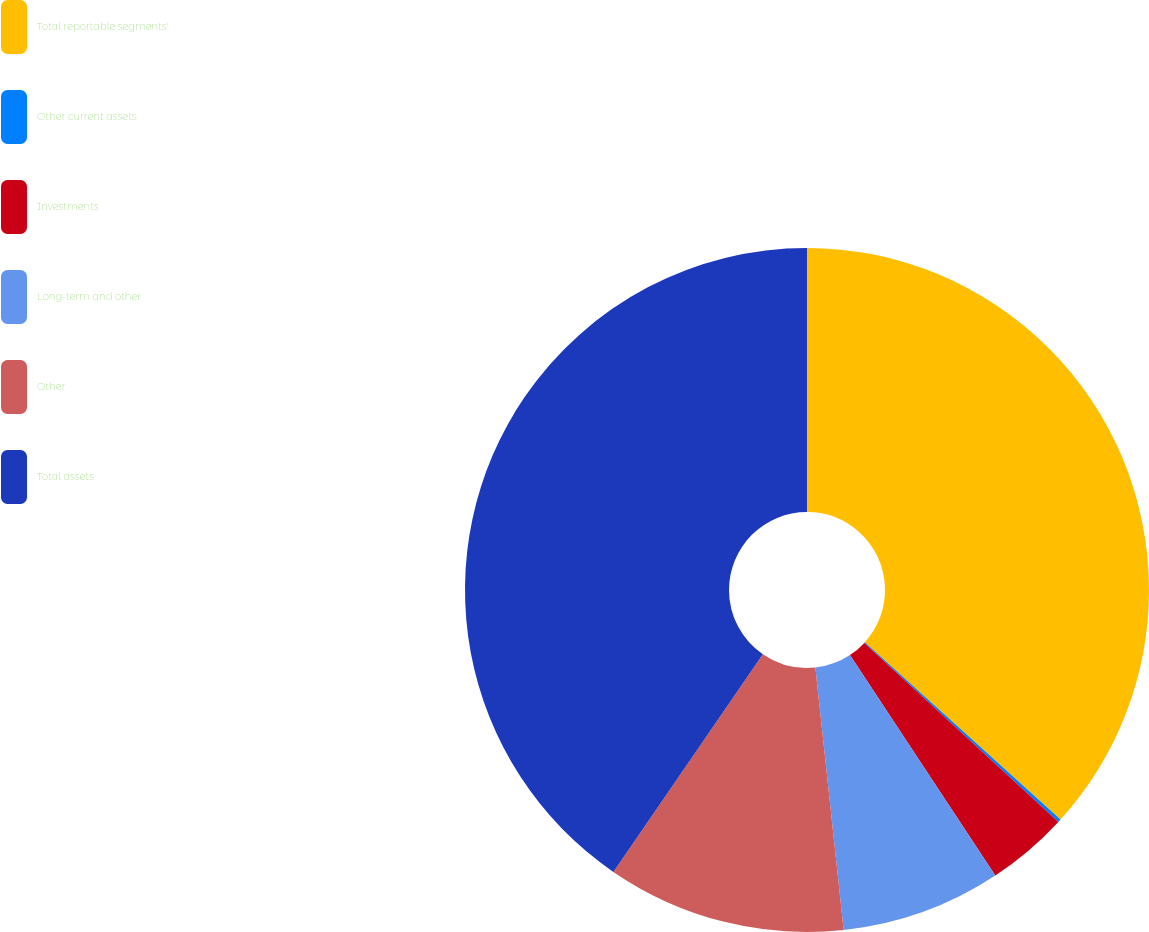Convert chart to OTSL. <chart><loc_0><loc_0><loc_500><loc_500><pie_chart><fcel>Total reportable segments'<fcel>Other current assets<fcel>Investments<fcel>Long-term and other<fcel>Other<fcel>Total assets<nl><fcel>36.71%<fcel>0.15%<fcel>3.86%<fcel>7.57%<fcel>11.29%<fcel>40.42%<nl></chart> 